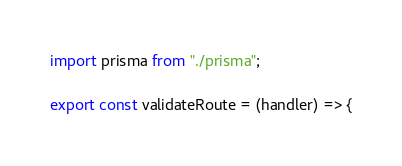<code> <loc_0><loc_0><loc_500><loc_500><_TypeScript_>import prisma from "./prisma";

export const validateRoute = (handler) => {</code> 